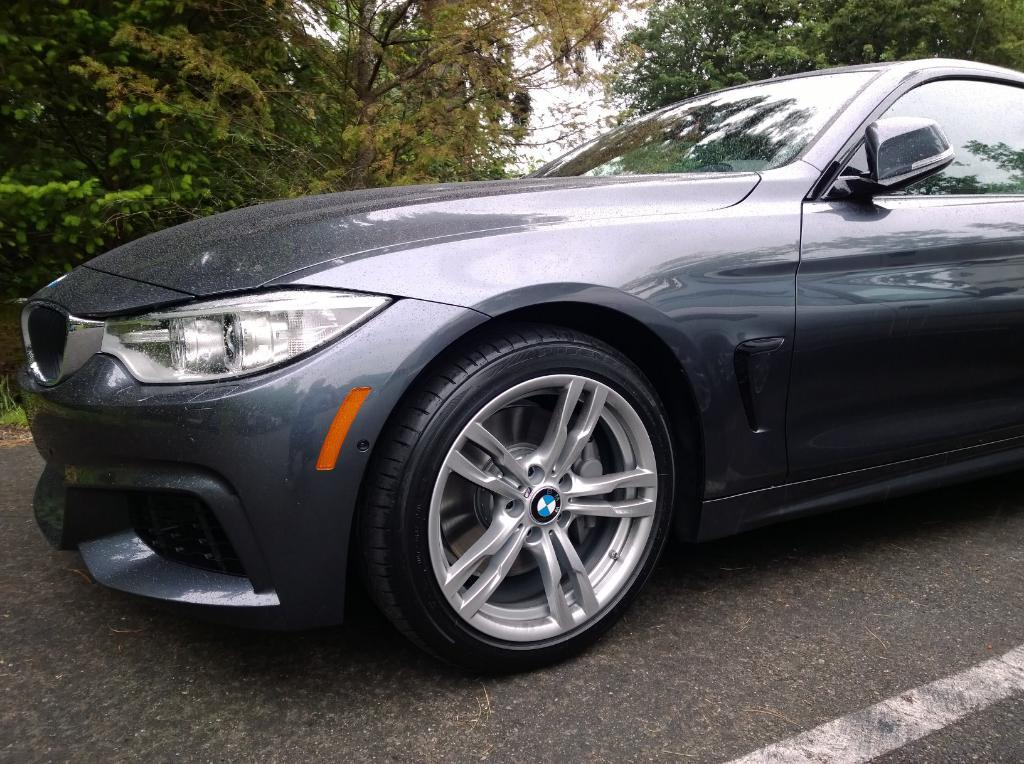What is the main subject of the image? The main subject of the image is a car. Where is the car located in the image? The car is on the road in the image. What color is the car? The car is grey in color. What can be seen in the background of the image? There are trees visible at the top of the image. Can you see a robin flying through the fog in the image? There is no robin or fog present in the image; it features a grey car on the road with trees visible in the background. 